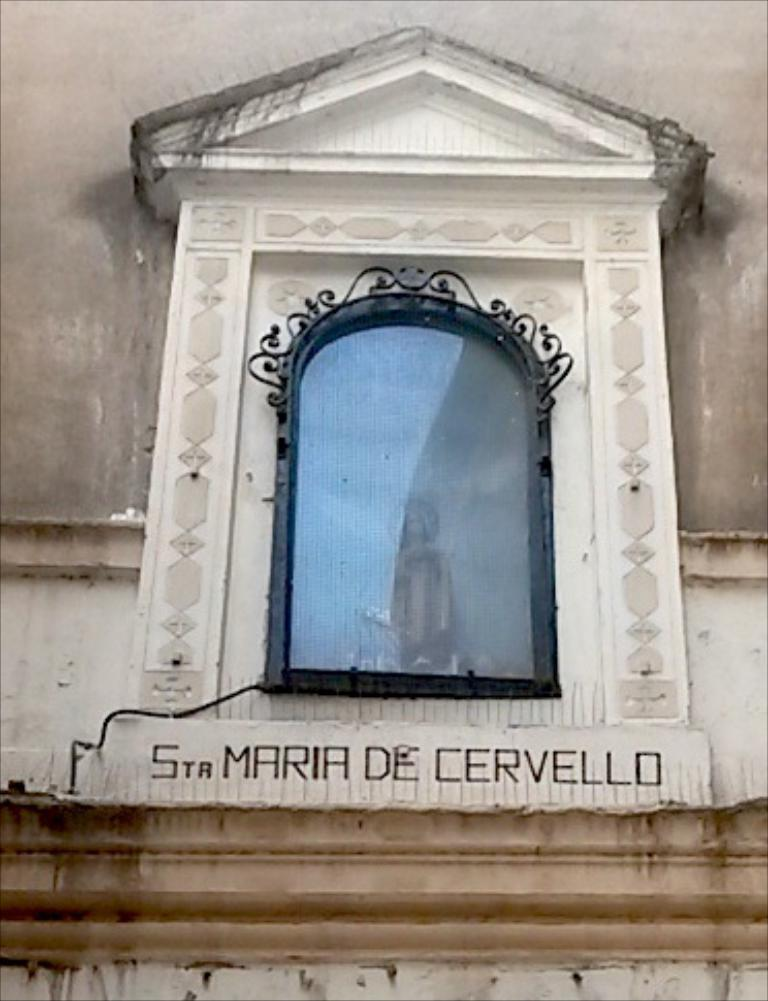What type of structure can be seen in the image? There is a wall in the image. What type of object is made of glass in the image? There is a glass object in the image. What type of artwork is present in the image? There is a sculpture in the image. What is written on the wall in the image? There is something written on the wall in the image. What type of pen is used to write on the wall in the image? There is no pen present in the image; the writing on the wall is not specified as being done with a pen. 